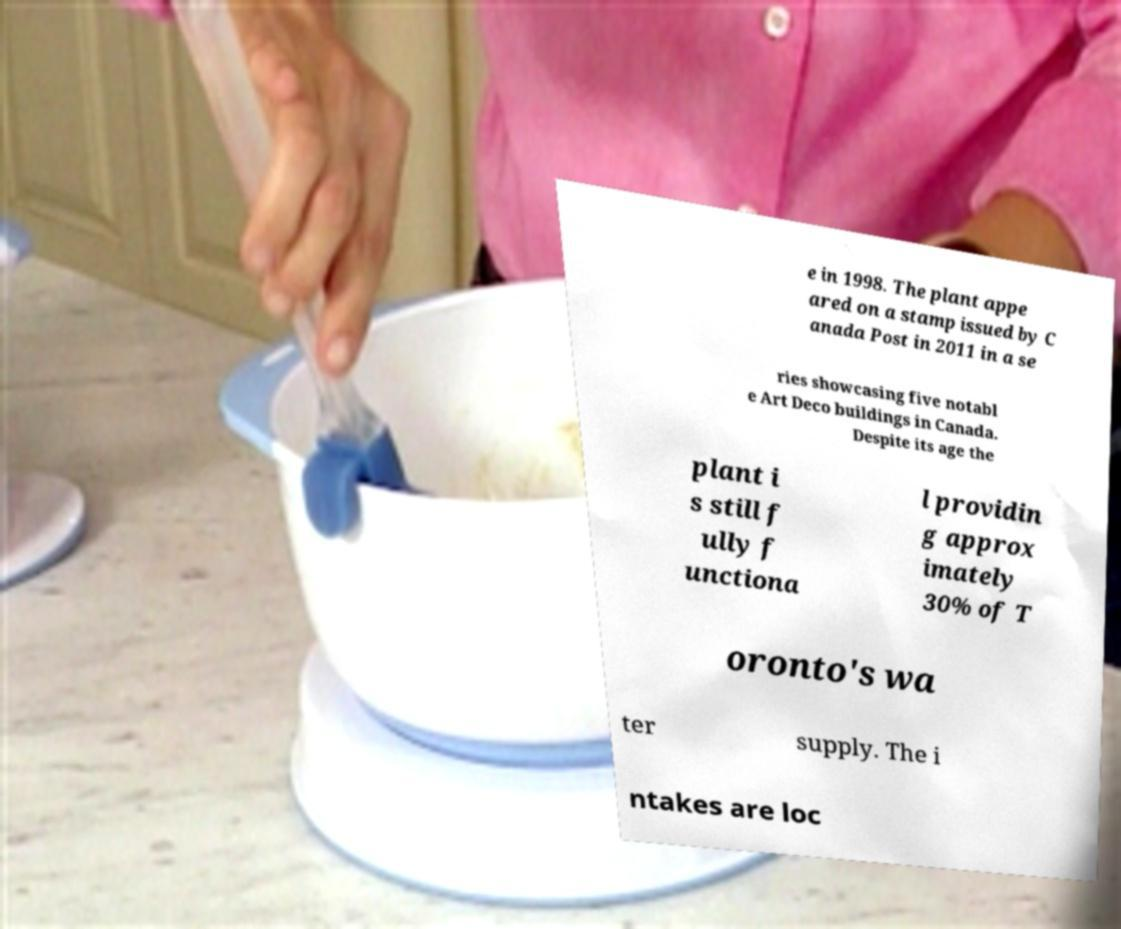For documentation purposes, I need the text within this image transcribed. Could you provide that? e in 1998. The plant appe ared on a stamp issued by C anada Post in 2011 in a se ries showcasing five notabl e Art Deco buildings in Canada. Despite its age the plant i s still f ully f unctiona l providin g approx imately 30% of T oronto's wa ter supply. The i ntakes are loc 